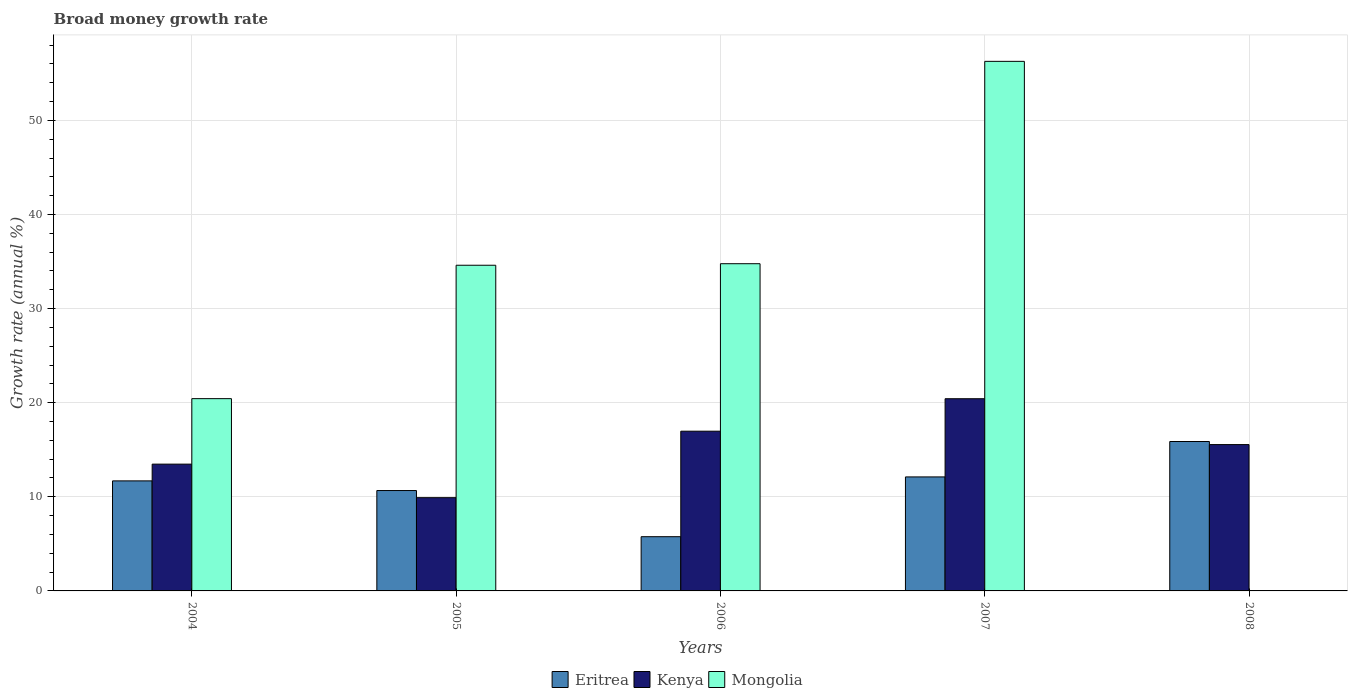How many different coloured bars are there?
Provide a short and direct response. 3. How many groups of bars are there?
Your answer should be very brief. 5. How many bars are there on the 5th tick from the left?
Make the answer very short. 2. What is the label of the 1st group of bars from the left?
Your answer should be very brief. 2004. What is the growth rate in Eritrea in 2007?
Your answer should be very brief. 12.11. Across all years, what is the maximum growth rate in Eritrea?
Give a very brief answer. 15.88. Across all years, what is the minimum growth rate in Mongolia?
Ensure brevity in your answer.  0. In which year was the growth rate in Eritrea maximum?
Ensure brevity in your answer.  2008. What is the total growth rate in Eritrea in the graph?
Your response must be concise. 56.11. What is the difference between the growth rate in Kenya in 2004 and that in 2005?
Make the answer very short. 3.56. What is the difference between the growth rate in Eritrea in 2007 and the growth rate in Kenya in 2008?
Make the answer very short. -3.44. What is the average growth rate in Eritrea per year?
Your response must be concise. 11.22. In the year 2005, what is the difference between the growth rate in Mongolia and growth rate in Kenya?
Your answer should be very brief. 24.7. In how many years, is the growth rate in Mongolia greater than 28 %?
Offer a very short reply. 3. What is the ratio of the growth rate in Kenya in 2004 to that in 2008?
Offer a very short reply. 0.87. Is the growth rate in Kenya in 2005 less than that in 2007?
Provide a succinct answer. Yes. What is the difference between the highest and the second highest growth rate in Kenya?
Keep it short and to the point. 3.45. What is the difference between the highest and the lowest growth rate in Eritrea?
Provide a short and direct response. 10.11. Is the sum of the growth rate in Eritrea in 2006 and 2007 greater than the maximum growth rate in Kenya across all years?
Your answer should be compact. No. Is it the case that in every year, the sum of the growth rate in Mongolia and growth rate in Kenya is greater than the growth rate in Eritrea?
Your answer should be very brief. No. How many years are there in the graph?
Offer a very short reply. 5. What is the title of the graph?
Your response must be concise. Broad money growth rate. Does "Iran" appear as one of the legend labels in the graph?
Offer a very short reply. No. What is the label or title of the X-axis?
Your response must be concise. Years. What is the label or title of the Y-axis?
Your response must be concise. Growth rate (annual %). What is the Growth rate (annual %) in Eritrea in 2004?
Offer a very short reply. 11.69. What is the Growth rate (annual %) in Kenya in 2004?
Offer a very short reply. 13.47. What is the Growth rate (annual %) of Mongolia in 2004?
Offer a terse response. 20.43. What is the Growth rate (annual %) of Eritrea in 2005?
Your answer should be compact. 10.67. What is the Growth rate (annual %) of Kenya in 2005?
Your response must be concise. 9.91. What is the Growth rate (annual %) in Mongolia in 2005?
Provide a short and direct response. 34.61. What is the Growth rate (annual %) of Eritrea in 2006?
Offer a very short reply. 5.76. What is the Growth rate (annual %) of Kenya in 2006?
Ensure brevity in your answer.  16.97. What is the Growth rate (annual %) of Mongolia in 2006?
Provide a succinct answer. 34.77. What is the Growth rate (annual %) of Eritrea in 2007?
Your answer should be compact. 12.11. What is the Growth rate (annual %) of Kenya in 2007?
Ensure brevity in your answer.  20.42. What is the Growth rate (annual %) of Mongolia in 2007?
Your answer should be very brief. 56.27. What is the Growth rate (annual %) in Eritrea in 2008?
Offer a terse response. 15.88. What is the Growth rate (annual %) of Kenya in 2008?
Provide a short and direct response. 15.55. Across all years, what is the maximum Growth rate (annual %) of Eritrea?
Your answer should be very brief. 15.88. Across all years, what is the maximum Growth rate (annual %) of Kenya?
Offer a very short reply. 20.42. Across all years, what is the maximum Growth rate (annual %) in Mongolia?
Provide a succinct answer. 56.27. Across all years, what is the minimum Growth rate (annual %) of Eritrea?
Provide a succinct answer. 5.76. Across all years, what is the minimum Growth rate (annual %) in Kenya?
Provide a short and direct response. 9.91. What is the total Growth rate (annual %) in Eritrea in the graph?
Your answer should be very brief. 56.11. What is the total Growth rate (annual %) in Kenya in the graph?
Ensure brevity in your answer.  76.32. What is the total Growth rate (annual %) of Mongolia in the graph?
Your answer should be very brief. 146.08. What is the difference between the Growth rate (annual %) of Eritrea in 2004 and that in 2005?
Offer a very short reply. 1.03. What is the difference between the Growth rate (annual %) of Kenya in 2004 and that in 2005?
Your response must be concise. 3.56. What is the difference between the Growth rate (annual %) of Mongolia in 2004 and that in 2005?
Keep it short and to the point. -14.18. What is the difference between the Growth rate (annual %) in Eritrea in 2004 and that in 2006?
Your answer should be very brief. 5.93. What is the difference between the Growth rate (annual %) in Kenya in 2004 and that in 2006?
Ensure brevity in your answer.  -3.5. What is the difference between the Growth rate (annual %) in Mongolia in 2004 and that in 2006?
Ensure brevity in your answer.  -14.34. What is the difference between the Growth rate (annual %) of Eritrea in 2004 and that in 2007?
Your answer should be very brief. -0.42. What is the difference between the Growth rate (annual %) of Kenya in 2004 and that in 2007?
Your answer should be very brief. -6.95. What is the difference between the Growth rate (annual %) in Mongolia in 2004 and that in 2007?
Keep it short and to the point. -35.84. What is the difference between the Growth rate (annual %) of Eritrea in 2004 and that in 2008?
Keep it short and to the point. -4.18. What is the difference between the Growth rate (annual %) in Kenya in 2004 and that in 2008?
Offer a terse response. -2.08. What is the difference between the Growth rate (annual %) of Eritrea in 2005 and that in 2006?
Your answer should be compact. 4.9. What is the difference between the Growth rate (annual %) of Kenya in 2005 and that in 2006?
Your response must be concise. -7.06. What is the difference between the Growth rate (annual %) of Mongolia in 2005 and that in 2006?
Provide a short and direct response. -0.16. What is the difference between the Growth rate (annual %) of Eritrea in 2005 and that in 2007?
Your answer should be compact. -1.45. What is the difference between the Growth rate (annual %) in Kenya in 2005 and that in 2007?
Provide a succinct answer. -10.51. What is the difference between the Growth rate (annual %) in Mongolia in 2005 and that in 2007?
Offer a very short reply. -21.66. What is the difference between the Growth rate (annual %) in Eritrea in 2005 and that in 2008?
Make the answer very short. -5.21. What is the difference between the Growth rate (annual %) in Kenya in 2005 and that in 2008?
Make the answer very short. -5.64. What is the difference between the Growth rate (annual %) in Eritrea in 2006 and that in 2007?
Offer a very short reply. -6.35. What is the difference between the Growth rate (annual %) of Kenya in 2006 and that in 2007?
Offer a terse response. -3.45. What is the difference between the Growth rate (annual %) in Mongolia in 2006 and that in 2007?
Provide a succinct answer. -21.5. What is the difference between the Growth rate (annual %) in Eritrea in 2006 and that in 2008?
Provide a succinct answer. -10.11. What is the difference between the Growth rate (annual %) of Kenya in 2006 and that in 2008?
Your answer should be compact. 1.42. What is the difference between the Growth rate (annual %) in Eritrea in 2007 and that in 2008?
Your response must be concise. -3.76. What is the difference between the Growth rate (annual %) of Kenya in 2007 and that in 2008?
Provide a succinct answer. 4.87. What is the difference between the Growth rate (annual %) of Eritrea in 2004 and the Growth rate (annual %) of Kenya in 2005?
Provide a short and direct response. 1.78. What is the difference between the Growth rate (annual %) of Eritrea in 2004 and the Growth rate (annual %) of Mongolia in 2005?
Your answer should be compact. -22.91. What is the difference between the Growth rate (annual %) in Kenya in 2004 and the Growth rate (annual %) in Mongolia in 2005?
Your answer should be compact. -21.13. What is the difference between the Growth rate (annual %) of Eritrea in 2004 and the Growth rate (annual %) of Kenya in 2006?
Ensure brevity in your answer.  -5.28. What is the difference between the Growth rate (annual %) in Eritrea in 2004 and the Growth rate (annual %) in Mongolia in 2006?
Make the answer very short. -23.08. What is the difference between the Growth rate (annual %) in Kenya in 2004 and the Growth rate (annual %) in Mongolia in 2006?
Offer a terse response. -21.3. What is the difference between the Growth rate (annual %) in Eritrea in 2004 and the Growth rate (annual %) in Kenya in 2007?
Offer a terse response. -8.73. What is the difference between the Growth rate (annual %) in Eritrea in 2004 and the Growth rate (annual %) in Mongolia in 2007?
Your response must be concise. -44.58. What is the difference between the Growth rate (annual %) in Kenya in 2004 and the Growth rate (annual %) in Mongolia in 2007?
Give a very brief answer. -42.8. What is the difference between the Growth rate (annual %) of Eritrea in 2004 and the Growth rate (annual %) of Kenya in 2008?
Your answer should be very brief. -3.86. What is the difference between the Growth rate (annual %) in Eritrea in 2005 and the Growth rate (annual %) in Kenya in 2006?
Ensure brevity in your answer.  -6.31. What is the difference between the Growth rate (annual %) of Eritrea in 2005 and the Growth rate (annual %) of Mongolia in 2006?
Your answer should be compact. -24.1. What is the difference between the Growth rate (annual %) in Kenya in 2005 and the Growth rate (annual %) in Mongolia in 2006?
Provide a succinct answer. -24.86. What is the difference between the Growth rate (annual %) of Eritrea in 2005 and the Growth rate (annual %) of Kenya in 2007?
Offer a very short reply. -9.76. What is the difference between the Growth rate (annual %) in Eritrea in 2005 and the Growth rate (annual %) in Mongolia in 2007?
Offer a very short reply. -45.61. What is the difference between the Growth rate (annual %) of Kenya in 2005 and the Growth rate (annual %) of Mongolia in 2007?
Ensure brevity in your answer.  -46.36. What is the difference between the Growth rate (annual %) in Eritrea in 2005 and the Growth rate (annual %) in Kenya in 2008?
Offer a very short reply. -4.88. What is the difference between the Growth rate (annual %) in Eritrea in 2006 and the Growth rate (annual %) in Kenya in 2007?
Offer a very short reply. -14.66. What is the difference between the Growth rate (annual %) in Eritrea in 2006 and the Growth rate (annual %) in Mongolia in 2007?
Offer a very short reply. -50.51. What is the difference between the Growth rate (annual %) of Kenya in 2006 and the Growth rate (annual %) of Mongolia in 2007?
Offer a terse response. -39.3. What is the difference between the Growth rate (annual %) of Eritrea in 2006 and the Growth rate (annual %) of Kenya in 2008?
Keep it short and to the point. -9.79. What is the difference between the Growth rate (annual %) of Eritrea in 2007 and the Growth rate (annual %) of Kenya in 2008?
Your answer should be very brief. -3.44. What is the average Growth rate (annual %) of Eritrea per year?
Offer a very short reply. 11.22. What is the average Growth rate (annual %) in Kenya per year?
Give a very brief answer. 15.26. What is the average Growth rate (annual %) in Mongolia per year?
Ensure brevity in your answer.  29.22. In the year 2004, what is the difference between the Growth rate (annual %) of Eritrea and Growth rate (annual %) of Kenya?
Your response must be concise. -1.78. In the year 2004, what is the difference between the Growth rate (annual %) of Eritrea and Growth rate (annual %) of Mongolia?
Your response must be concise. -8.74. In the year 2004, what is the difference between the Growth rate (annual %) of Kenya and Growth rate (annual %) of Mongolia?
Your response must be concise. -6.96. In the year 2005, what is the difference between the Growth rate (annual %) of Eritrea and Growth rate (annual %) of Kenya?
Keep it short and to the point. 0.76. In the year 2005, what is the difference between the Growth rate (annual %) in Eritrea and Growth rate (annual %) in Mongolia?
Your answer should be very brief. -23.94. In the year 2005, what is the difference between the Growth rate (annual %) in Kenya and Growth rate (annual %) in Mongolia?
Provide a short and direct response. -24.7. In the year 2006, what is the difference between the Growth rate (annual %) of Eritrea and Growth rate (annual %) of Kenya?
Make the answer very short. -11.21. In the year 2006, what is the difference between the Growth rate (annual %) in Eritrea and Growth rate (annual %) in Mongolia?
Offer a terse response. -29.01. In the year 2006, what is the difference between the Growth rate (annual %) of Kenya and Growth rate (annual %) of Mongolia?
Give a very brief answer. -17.8. In the year 2007, what is the difference between the Growth rate (annual %) in Eritrea and Growth rate (annual %) in Kenya?
Offer a terse response. -8.31. In the year 2007, what is the difference between the Growth rate (annual %) of Eritrea and Growth rate (annual %) of Mongolia?
Provide a short and direct response. -44.16. In the year 2007, what is the difference between the Growth rate (annual %) in Kenya and Growth rate (annual %) in Mongolia?
Give a very brief answer. -35.85. In the year 2008, what is the difference between the Growth rate (annual %) of Eritrea and Growth rate (annual %) of Kenya?
Your answer should be very brief. 0.33. What is the ratio of the Growth rate (annual %) of Eritrea in 2004 to that in 2005?
Keep it short and to the point. 1.1. What is the ratio of the Growth rate (annual %) of Kenya in 2004 to that in 2005?
Provide a short and direct response. 1.36. What is the ratio of the Growth rate (annual %) of Mongolia in 2004 to that in 2005?
Your response must be concise. 0.59. What is the ratio of the Growth rate (annual %) in Eritrea in 2004 to that in 2006?
Your answer should be compact. 2.03. What is the ratio of the Growth rate (annual %) in Kenya in 2004 to that in 2006?
Make the answer very short. 0.79. What is the ratio of the Growth rate (annual %) of Mongolia in 2004 to that in 2006?
Your response must be concise. 0.59. What is the ratio of the Growth rate (annual %) in Eritrea in 2004 to that in 2007?
Your response must be concise. 0.97. What is the ratio of the Growth rate (annual %) of Kenya in 2004 to that in 2007?
Your response must be concise. 0.66. What is the ratio of the Growth rate (annual %) of Mongolia in 2004 to that in 2007?
Keep it short and to the point. 0.36. What is the ratio of the Growth rate (annual %) of Eritrea in 2004 to that in 2008?
Offer a very short reply. 0.74. What is the ratio of the Growth rate (annual %) in Kenya in 2004 to that in 2008?
Offer a very short reply. 0.87. What is the ratio of the Growth rate (annual %) of Eritrea in 2005 to that in 2006?
Your answer should be compact. 1.85. What is the ratio of the Growth rate (annual %) of Kenya in 2005 to that in 2006?
Offer a terse response. 0.58. What is the ratio of the Growth rate (annual %) of Eritrea in 2005 to that in 2007?
Give a very brief answer. 0.88. What is the ratio of the Growth rate (annual %) of Kenya in 2005 to that in 2007?
Provide a succinct answer. 0.49. What is the ratio of the Growth rate (annual %) in Mongolia in 2005 to that in 2007?
Offer a terse response. 0.61. What is the ratio of the Growth rate (annual %) in Eritrea in 2005 to that in 2008?
Your answer should be very brief. 0.67. What is the ratio of the Growth rate (annual %) of Kenya in 2005 to that in 2008?
Keep it short and to the point. 0.64. What is the ratio of the Growth rate (annual %) of Eritrea in 2006 to that in 2007?
Provide a succinct answer. 0.48. What is the ratio of the Growth rate (annual %) in Kenya in 2006 to that in 2007?
Your answer should be very brief. 0.83. What is the ratio of the Growth rate (annual %) in Mongolia in 2006 to that in 2007?
Your response must be concise. 0.62. What is the ratio of the Growth rate (annual %) of Eritrea in 2006 to that in 2008?
Your answer should be very brief. 0.36. What is the ratio of the Growth rate (annual %) of Kenya in 2006 to that in 2008?
Give a very brief answer. 1.09. What is the ratio of the Growth rate (annual %) in Eritrea in 2007 to that in 2008?
Provide a succinct answer. 0.76. What is the ratio of the Growth rate (annual %) of Kenya in 2007 to that in 2008?
Make the answer very short. 1.31. What is the difference between the highest and the second highest Growth rate (annual %) of Eritrea?
Offer a terse response. 3.76. What is the difference between the highest and the second highest Growth rate (annual %) of Kenya?
Offer a terse response. 3.45. What is the difference between the highest and the second highest Growth rate (annual %) in Mongolia?
Your response must be concise. 21.5. What is the difference between the highest and the lowest Growth rate (annual %) in Eritrea?
Your answer should be compact. 10.11. What is the difference between the highest and the lowest Growth rate (annual %) in Kenya?
Provide a short and direct response. 10.51. What is the difference between the highest and the lowest Growth rate (annual %) of Mongolia?
Offer a terse response. 56.27. 